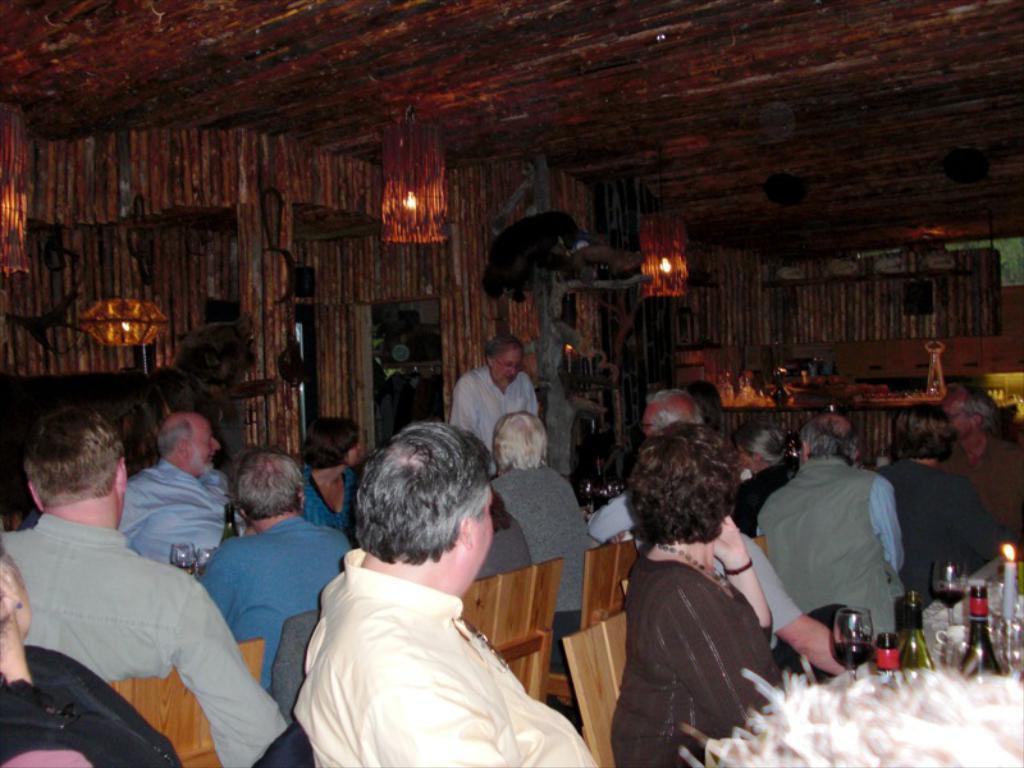Please provide a concise description of this image. In this image I can see number of persons are sitting on chairs which are brown in color in front of tables. On the tables I can see few glasses, few bottles and candles. In the background I can see a person standing, the wooden wall , the ceiling and few lamps. 